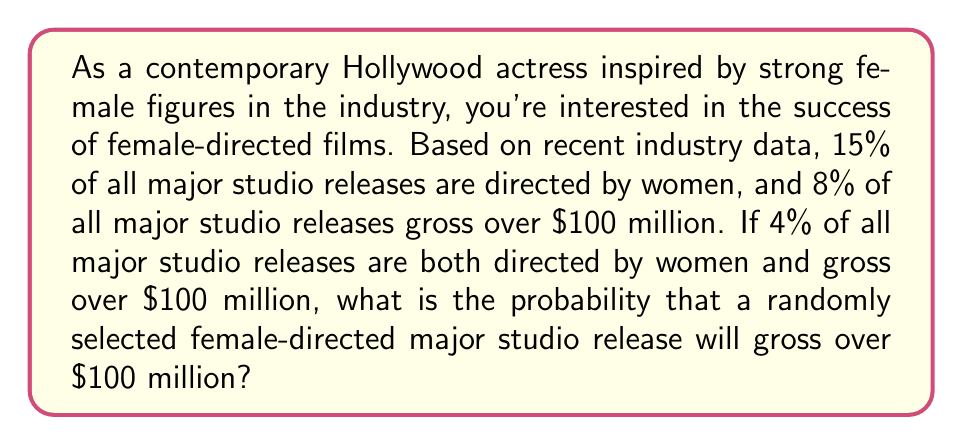Can you answer this question? Let's approach this step-by-step using conditional probability:

1) Let's define our events:
   A: The film is directed by a woman
   B: The film grosses over $100 million

2) We're given the following probabilities:
   $P(A) = 0.15$ (15% of films are directed by women)
   $P(B) = 0.08$ (8% of films gross over $100 million)
   $P(A \cap B) = 0.04$ (4% of films are both directed by women and gross over $100 million)

3) We're asked to find $P(B|A)$, which is the probability that a film grosses over $100 million given that it's directed by a woman.

4) We can use the formula for conditional probability:

   $$P(B|A) = \frac{P(A \cap B)}{P(A)}$$

5) Substituting our known values:

   $$P(B|A) = \frac{0.04}{0.15}$$

6) Calculating:

   $$P(B|A) = \frac{4}{15} \approx 0.2667$$
Answer: The probability that a randomly selected female-directed major studio release will gross over $100 million is $\frac{4}{15}$ or approximately 26.67%. 